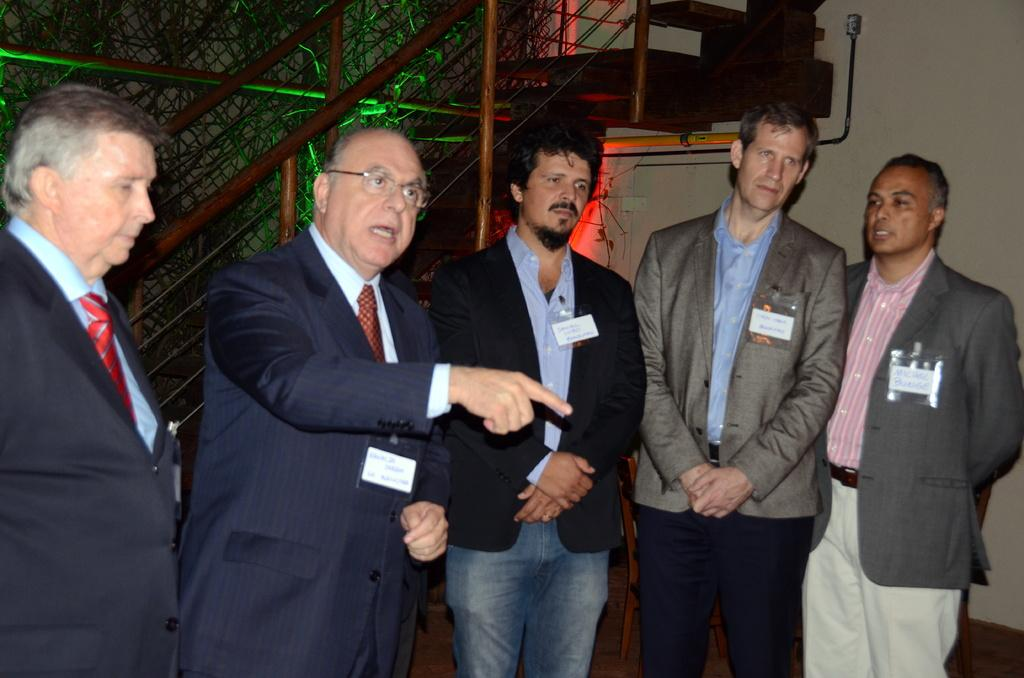What can be seen in the image? There are people standing in the image. What architectural feature is visible in the background? There are stairs visible in the background of the image. What is on the wall in the image? There is a mesh on the wall in the image. Can you see a stream flowing near the people in the image? No, there is no stream visible in the image. 